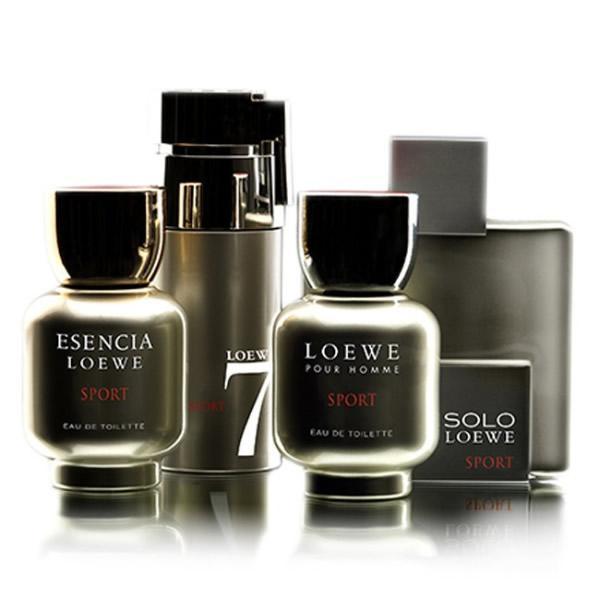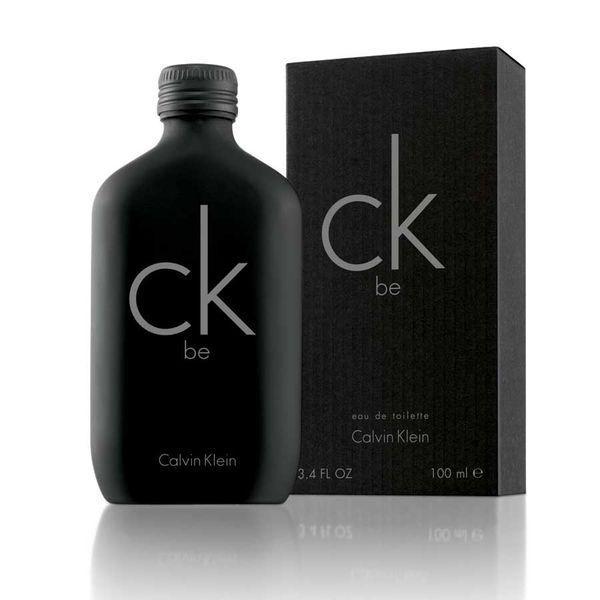The first image is the image on the left, the second image is the image on the right. Given the left and right images, does the statement "An image shows a trio of fragance bottles of the same size and shape, displayed in a triangular formation." hold true? Answer yes or no. No. The first image is the image on the left, the second image is the image on the right. Considering the images on both sides, is "There is one more container in the image on the left than there is in the image on the right." valid? Answer yes or no. No. 